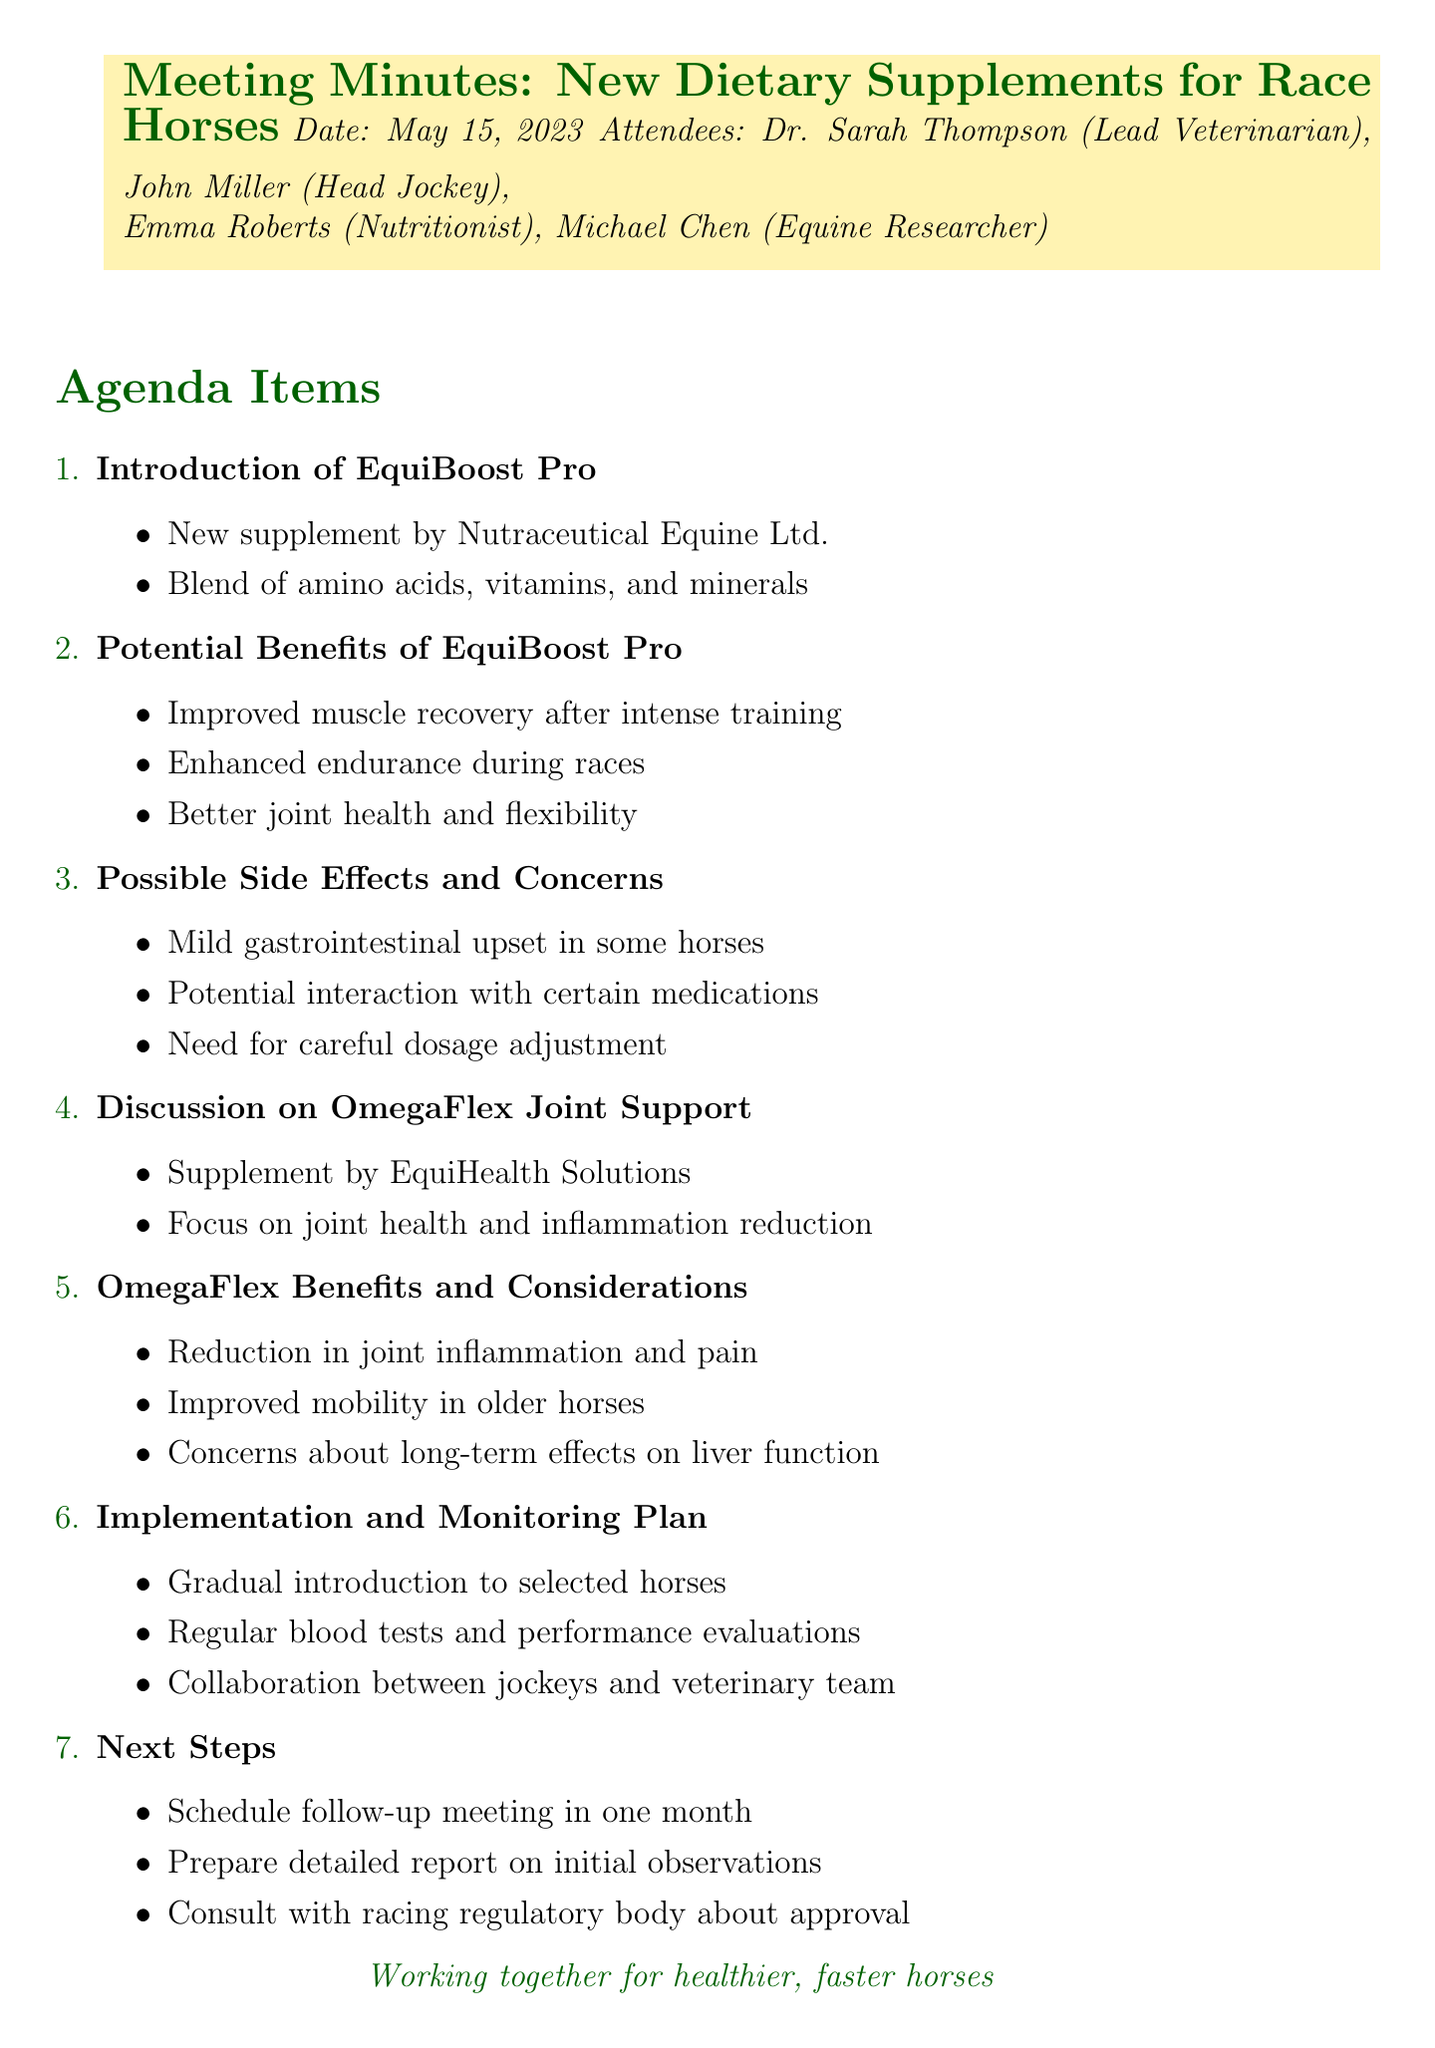What is the title of the meeting? The title of the meeting is stated at the beginning of the document.
Answer: New Dietary Supplements for Race Horses When was the meeting held? The date of the meeting is provided in the document header.
Answer: May 15, 2023 Who is the lead veterinarian? The lead veterinarian’s name is mentioned in the list of attendees.
Answer: Dr. Sarah Thompson What company developed EquiBoost Pro? The document states the developing company in the introduction of EquiBoost Pro.
Answer: Nutraceutical Equine Ltd What is one potential benefit of EquiBoost Pro? The potential benefits are listed under a specific agenda item.
Answer: Improved muscle recovery after intense training What is a possible side effect of EquiBoost Pro? The document mentions side effects under the Possible Side Effects and Concerns section.
Answer: Mild gastrointestinal upset What is the focus of OmegaFlex Joint Support? The document outlines the main focus in the discussion on OmegaFlex Joint Support.
Answer: Joint health and inflammation reduction What is included in the implementation plan? The implementation and monitoring plan itemizes actions to be taken regarding the supplements.
Answer: Gradual introduction of supplements to selected horses How often will follow-up meetings be scheduled? The next steps section mentions the frequency of follow-up meetings.
Answer: In one month What should be prepared after the initial observations? The document outlines what needs to be prepared under next steps.
Answer: Detailed report on initial observations 